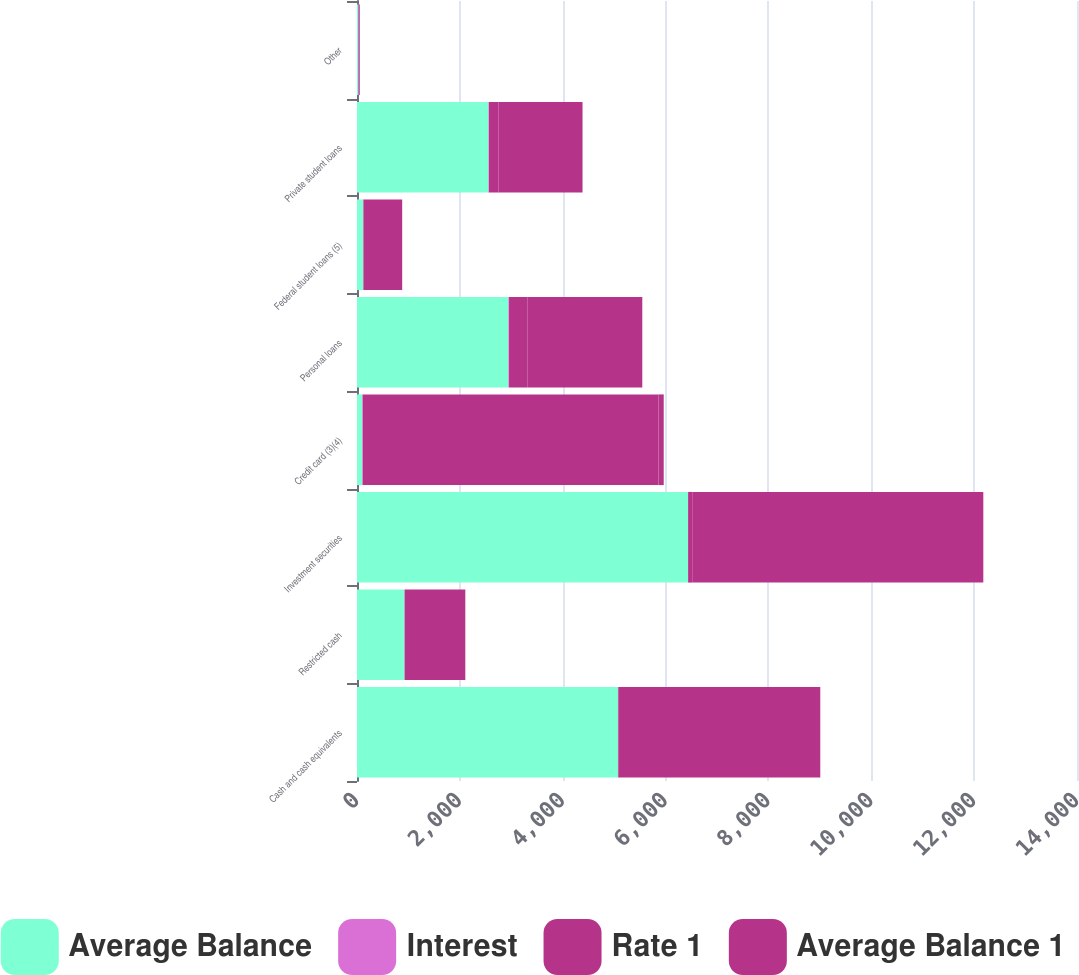Convert chart. <chart><loc_0><loc_0><loc_500><loc_500><stacked_bar_chart><ecel><fcel>Cash and cash equivalents<fcel>Restricted cash<fcel>Investment securities<fcel>Credit card (3)(4)<fcel>Personal loans<fcel>Federal student loans (5)<fcel>Private student loans<fcel>Other<nl><fcel>Average Balance<fcel>5074<fcel>924<fcel>6437<fcel>100.5<fcel>2944<fcel>121<fcel>2557<fcel>26<nl><fcel>Interest<fcel>0.27<fcel>0.15<fcel>1.24<fcel>12.16<fcel>12.35<fcel>1.64<fcel>7.2<fcel>11.98<nl><fcel>Rate 1<fcel>14<fcel>2<fcel>80<fcel>5751<fcel>363<fcel>2<fcel>184<fcel>3<nl><fcel>Average Balance 1<fcel>3920<fcel>1180<fcel>5660<fcel>100.5<fcel>2228<fcel>754<fcel>1637<fcel>14<nl></chart> 